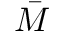<formula> <loc_0><loc_0><loc_500><loc_500>\bar { M }</formula> 